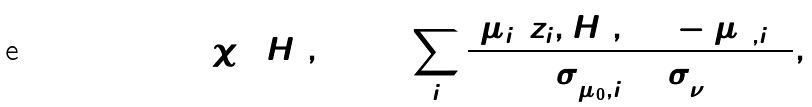Convert formula to latex. <formula><loc_0><loc_0><loc_500><loc_500>\chi ^ { 2 } ( H _ { 0 } , \Omega ) = \sum _ { i } \frac { \left [ \mu _ { i } ( z _ { i } , H _ { 0 } , \Omega ) - \mu _ { 0 , i } \right ] ^ { 2 } } { \sigma _ { \mu _ { 0 } , i } ^ { 2 } + \sigma _ { \nu } ^ { 2 } } ,</formula> 